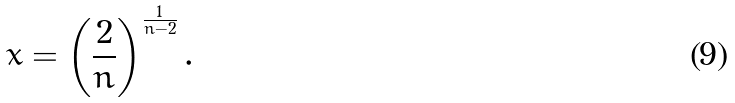Convert formula to latex. <formula><loc_0><loc_0><loc_500><loc_500>x = \left ( \frac { 2 } { n } \right ) ^ { \frac { 1 } { n - 2 } } .</formula> 